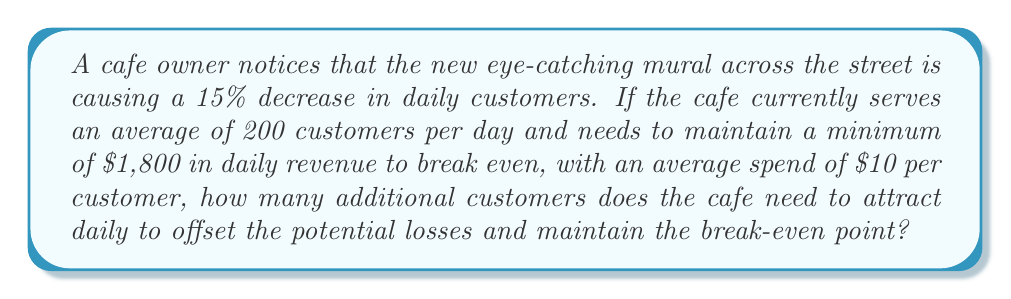Could you help me with this problem? Let's approach this problem step-by-step:

1) First, calculate the number of customers lost due to the mural:
   $15\% \text{ of } 200 = 0.15 \times 200 = 30$ customers

2) Calculate the new number of customers after the decrease:
   $200 - 30 = 170$ customers

3) Calculate the current revenue after the decrease:
   $170 \text{ customers} \times $10 \text{ per customer} = $1,700$

4) Calculate the revenue shortfall:
   $1,800 \text{ (break-even)} - $1,700 \text{ (current)} = $100$

5) Calculate the number of additional customers needed to make up the shortfall:
   $$\frac{\text{Revenue shortfall}}{\text{Average spend per customer}} = \frac{$100}{$10 \text{ per customer}} = 10 \text{ customers}$$

Therefore, the cafe needs to attract 10 additional customers daily to offset the losses and maintain the break-even point.
Answer: 10 additional customers 